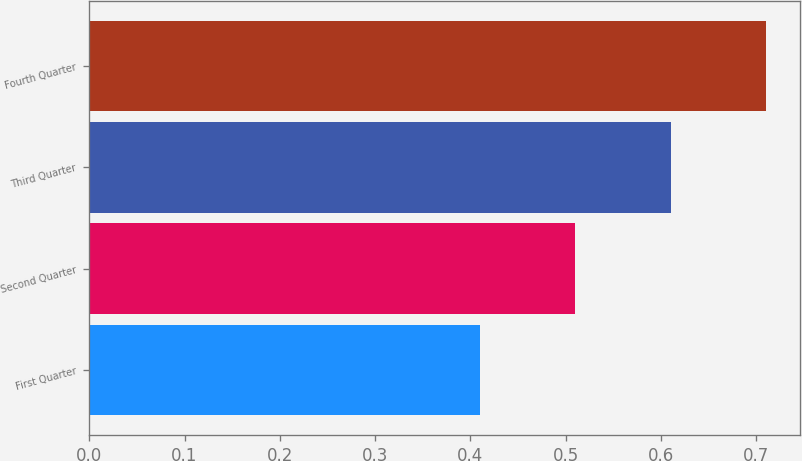Convert chart. <chart><loc_0><loc_0><loc_500><loc_500><bar_chart><fcel>First Quarter<fcel>Second Quarter<fcel>Third Quarter<fcel>Fourth Quarter<nl><fcel>0.41<fcel>0.51<fcel>0.61<fcel>0.71<nl></chart> 